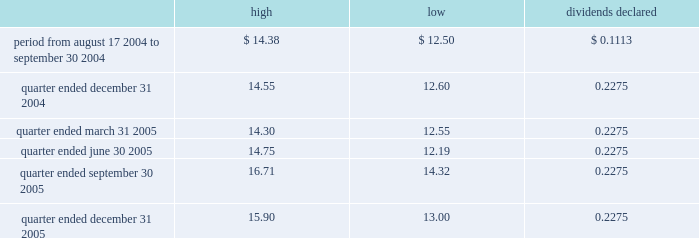Part ii item 5 .
Market for registrant 2019s common equity and related stockholder matters market information our common stock has been traded on the new york stock exchange ( 2018 2018nyse 2019 2019 ) under the symbol 2018 2018exr 2019 2019 since our ipo on august 17 , 2004 .
Prior to that time there was no public market for our common stock .
The table sets forth , for the periods indicated , the high and low bid price for our common stock as reported by the nyse and the per share dividends declared : dividends high low declared .
On february 28 , 2006 , the closing price of our common stock as reported by the nyse was $ 15.00 .
At february 28 , 2006 , we had 166 holders of record of our common stock .
Holders of shares of common stock are entitled to receive distributions when declared by our board of directors out of any assets legally available for that purpose .
As a reit , we are required to distribute at least 90% ( 90 % ) of our 2018 2018reit taxable income 2019 2019 is generally equivalent to our net taxable ordinary income , determined without regard to the deduction for dividends paid , to our stockholders annually in order to maintain our reit qualifications for u.s .
Federal income tax purposes .
Unregistered sales of equity securities and use of proceeds on june 20 , 2005 , we completed the sale of 6200000 shares of our common stock , $ .01 par value , for $ 83514 , which we reported in a current report on form 8-k filed with the securities and exchange commission on june 24 , 2005 .
We used the proceeds for general corporate purposes , including debt repayment .
The shares were issued pursuant to an exemption from registration under the securities act of 1933 , as amended. .
Using the high bid price what was the percentage difference between the quarter ended december 31 , 2004 and the quarter ended march 312005? 
Computations: ((14.30 - 14.55) / 14.55)
Answer: -0.01718. 